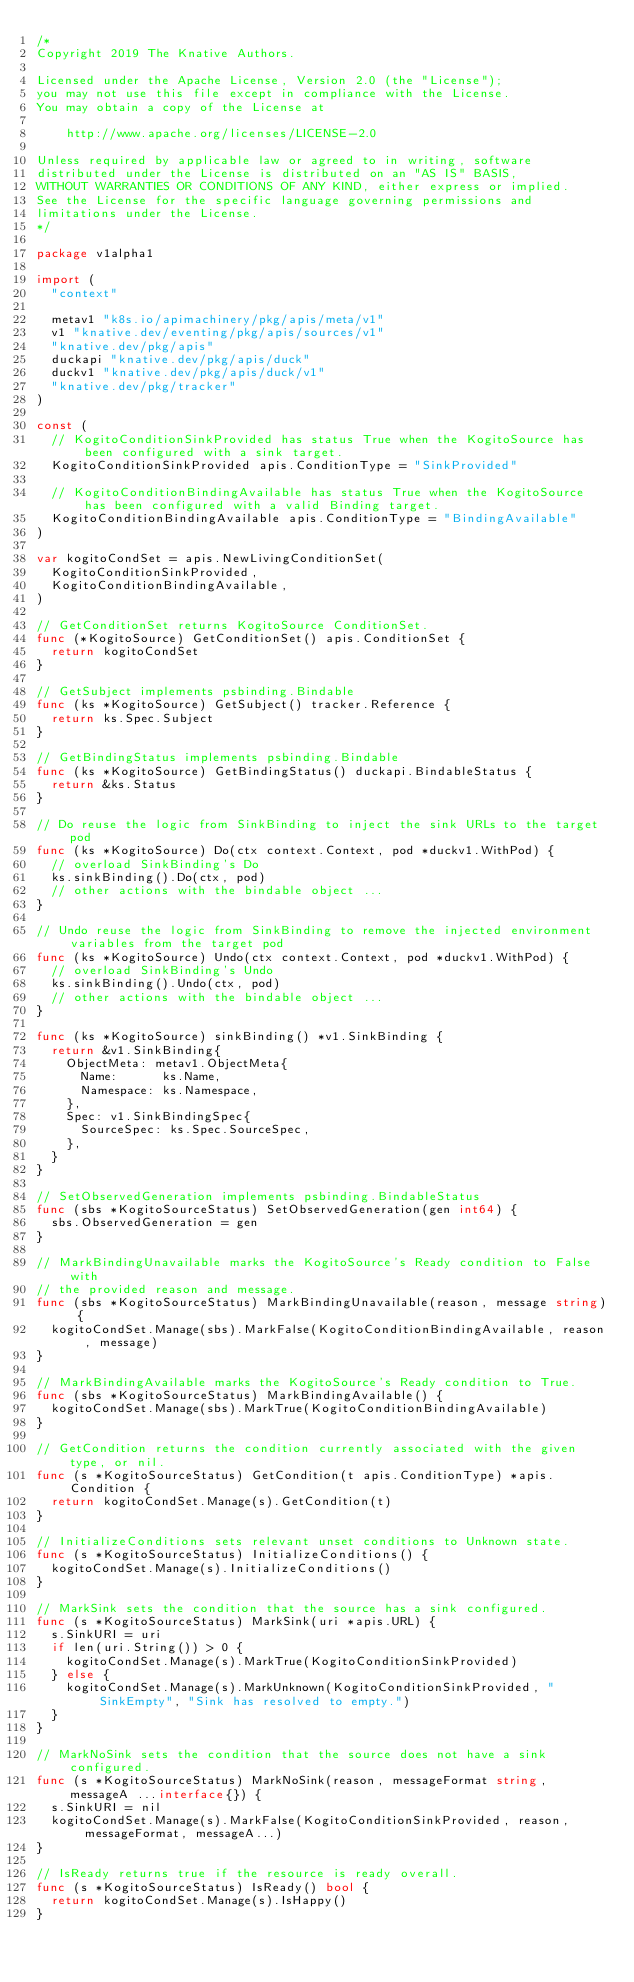Convert code to text. <code><loc_0><loc_0><loc_500><loc_500><_Go_>/*
Copyright 2019 The Knative Authors.

Licensed under the Apache License, Version 2.0 (the "License");
you may not use this file except in compliance with the License.
You may obtain a copy of the License at

    http://www.apache.org/licenses/LICENSE-2.0

Unless required by applicable law or agreed to in writing, software
distributed under the License is distributed on an "AS IS" BASIS,
WITHOUT WARRANTIES OR CONDITIONS OF ANY KIND, either express or implied.
See the License for the specific language governing permissions and
limitations under the License.
*/

package v1alpha1

import (
	"context"

	metav1 "k8s.io/apimachinery/pkg/apis/meta/v1"
	v1 "knative.dev/eventing/pkg/apis/sources/v1"
	"knative.dev/pkg/apis"
	duckapi "knative.dev/pkg/apis/duck"
	duckv1 "knative.dev/pkg/apis/duck/v1"
	"knative.dev/pkg/tracker"
)

const (
	// KogitoConditionSinkProvided has status True when the KogitoSource has been configured with a sink target.
	KogitoConditionSinkProvided apis.ConditionType = "SinkProvided"

	// KogitoConditionBindingAvailable has status True when the KogitoSource has been configured with a valid Binding target.
	KogitoConditionBindingAvailable apis.ConditionType = "BindingAvailable"
)

var kogitoCondSet = apis.NewLivingConditionSet(
	KogitoConditionSinkProvided,
	KogitoConditionBindingAvailable,
)

// GetConditionSet returns KogitoSource ConditionSet.
func (*KogitoSource) GetConditionSet() apis.ConditionSet {
	return kogitoCondSet
}

// GetSubject implements psbinding.Bindable
func (ks *KogitoSource) GetSubject() tracker.Reference {
	return ks.Spec.Subject
}

// GetBindingStatus implements psbinding.Bindable
func (ks *KogitoSource) GetBindingStatus() duckapi.BindableStatus {
	return &ks.Status
}

// Do reuse the logic from SinkBinding to inject the sink URLs to the target pod
func (ks *KogitoSource) Do(ctx context.Context, pod *duckv1.WithPod) {
	// overload SinkBinding's Do
	ks.sinkBinding().Do(ctx, pod)
	// other actions with the bindable object ...
}

// Undo reuse the logic from SinkBinding to remove the injected environment variables from the target pod
func (ks *KogitoSource) Undo(ctx context.Context, pod *duckv1.WithPod) {
	// overload SinkBinding's Undo
	ks.sinkBinding().Undo(ctx, pod)
	// other actions with the bindable object ...
}

func (ks *KogitoSource) sinkBinding() *v1.SinkBinding {
	return &v1.SinkBinding{
		ObjectMeta: metav1.ObjectMeta{
			Name:      ks.Name,
			Namespace: ks.Namespace,
		},
		Spec: v1.SinkBindingSpec{
			SourceSpec: ks.Spec.SourceSpec,
		},
	}
}

// SetObservedGeneration implements psbinding.BindableStatus
func (sbs *KogitoSourceStatus) SetObservedGeneration(gen int64) {
	sbs.ObservedGeneration = gen
}

// MarkBindingUnavailable marks the KogitoSource's Ready condition to False with
// the provided reason and message.
func (sbs *KogitoSourceStatus) MarkBindingUnavailable(reason, message string) {
	kogitoCondSet.Manage(sbs).MarkFalse(KogitoConditionBindingAvailable, reason, message)
}

// MarkBindingAvailable marks the KogitoSource's Ready condition to True.
func (sbs *KogitoSourceStatus) MarkBindingAvailable() {
	kogitoCondSet.Manage(sbs).MarkTrue(KogitoConditionBindingAvailable)
}

// GetCondition returns the condition currently associated with the given type, or nil.
func (s *KogitoSourceStatus) GetCondition(t apis.ConditionType) *apis.Condition {
	return kogitoCondSet.Manage(s).GetCondition(t)
}

// InitializeConditions sets relevant unset conditions to Unknown state.
func (s *KogitoSourceStatus) InitializeConditions() {
	kogitoCondSet.Manage(s).InitializeConditions()
}

// MarkSink sets the condition that the source has a sink configured.
func (s *KogitoSourceStatus) MarkSink(uri *apis.URL) {
	s.SinkURI = uri
	if len(uri.String()) > 0 {
		kogitoCondSet.Manage(s).MarkTrue(KogitoConditionSinkProvided)
	} else {
		kogitoCondSet.Manage(s).MarkUnknown(KogitoConditionSinkProvided, "SinkEmpty", "Sink has resolved to empty.")
	}
}

// MarkNoSink sets the condition that the source does not have a sink configured.
func (s *KogitoSourceStatus) MarkNoSink(reason, messageFormat string, messageA ...interface{}) {
	s.SinkURI = nil
	kogitoCondSet.Manage(s).MarkFalse(KogitoConditionSinkProvided, reason, messageFormat, messageA...)
}

// IsReady returns true if the resource is ready overall.
func (s *KogitoSourceStatus) IsReady() bool {
	return kogitoCondSet.Manage(s).IsHappy()
}
</code> 